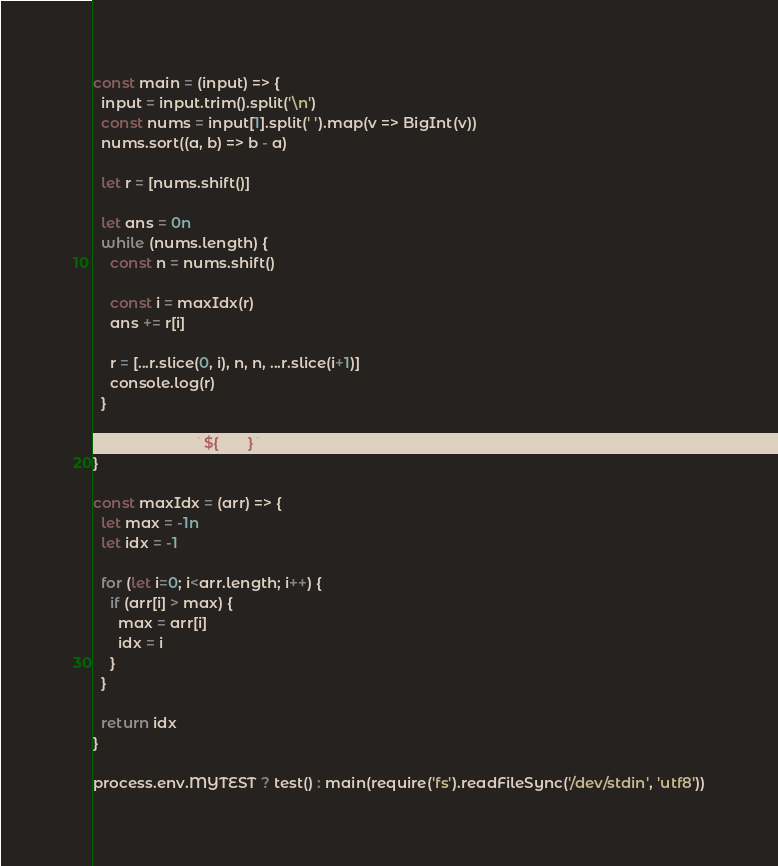<code> <loc_0><loc_0><loc_500><loc_500><_JavaScript_>const main = (input) => {
  input = input.trim().split('\n')
  const nums = input[1].split(' ').map(v => BigInt(v))
  nums.sort((a, b) => b - a)

  let r = [nums.shift()]

  let ans = 0n
  while (nums.length) {
    const n = nums.shift()

    const i = maxIdx(r)
    ans += r[i]

    r = [...r.slice(0, i), n, n, ...r.slice(i+1)]
    console.log(r)
  }

  console.log(`${ans}`)
}

const maxIdx = (arr) => {
  let max = -1n
  let idx = -1

  for (let i=0; i<arr.length; i++) {
    if (arr[i] > max) {
      max = arr[i]
      idx = i
    }
  }

  return idx
}

process.env.MYTEST ? test() : main(require('fs').readFileSync('/dev/stdin', 'utf8'))</code> 